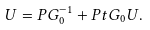<formula> <loc_0><loc_0><loc_500><loc_500>U = P G _ { 0 } ^ { - 1 } + P t G _ { 0 } U .</formula> 